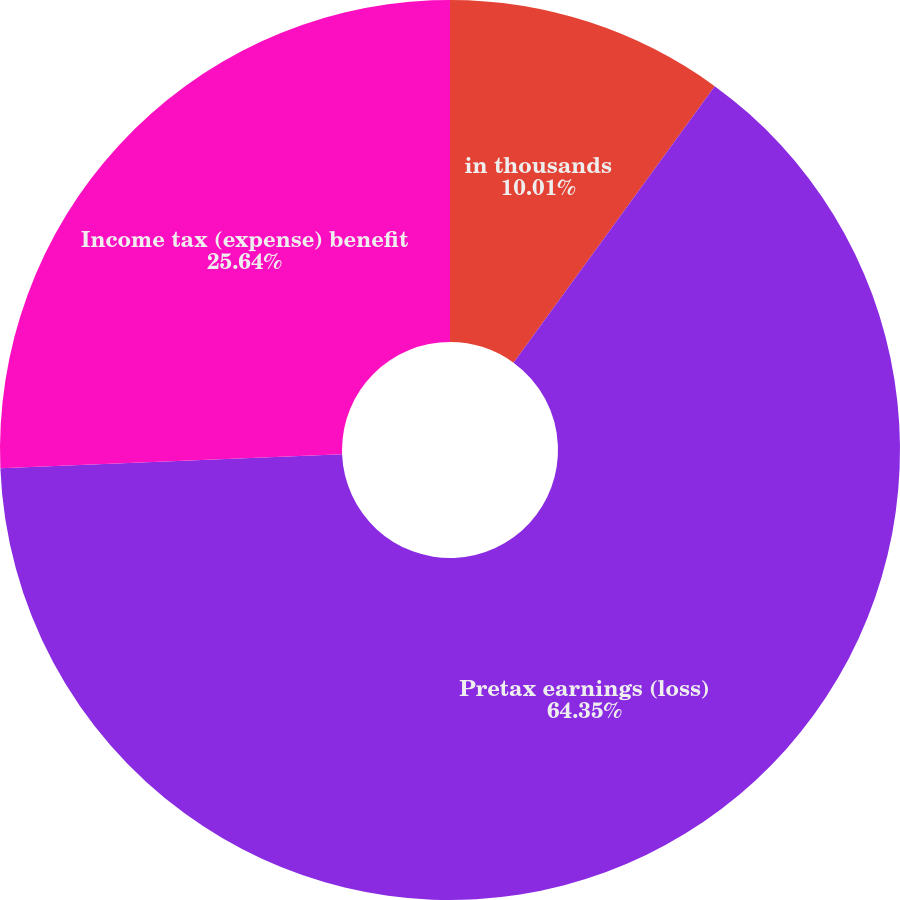Convert chart. <chart><loc_0><loc_0><loc_500><loc_500><pie_chart><fcel>in thousands<fcel>Pretax earnings (loss)<fcel>Income tax (expense) benefit<nl><fcel>10.01%<fcel>64.34%<fcel>25.64%<nl></chart> 